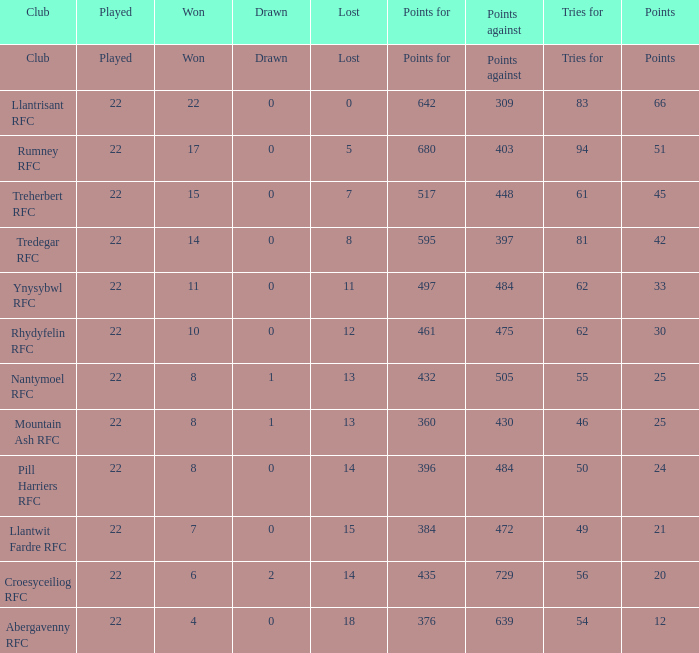How many tries for were scored by the team that had exactly 396 points for? 50.0. 